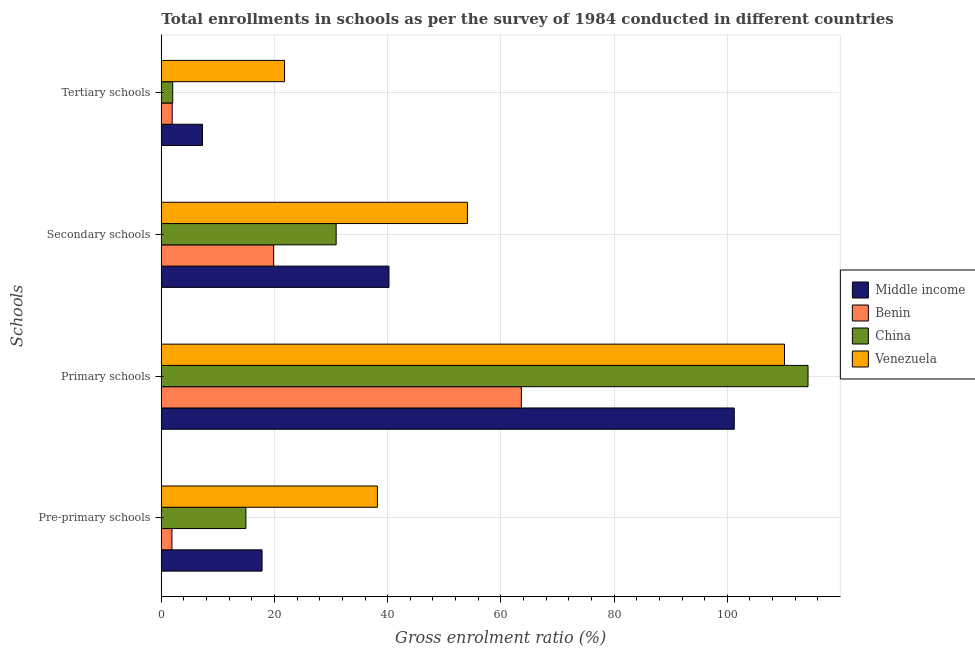How many different coloured bars are there?
Your answer should be very brief. 4. How many groups of bars are there?
Give a very brief answer. 4. Are the number of bars per tick equal to the number of legend labels?
Give a very brief answer. Yes. What is the label of the 1st group of bars from the top?
Your answer should be compact. Tertiary schools. What is the gross enrolment ratio in pre-primary schools in Middle income?
Offer a very short reply. 17.8. Across all countries, what is the maximum gross enrolment ratio in tertiary schools?
Your answer should be very brief. 21.77. Across all countries, what is the minimum gross enrolment ratio in secondary schools?
Provide a succinct answer. 19.84. In which country was the gross enrolment ratio in primary schools maximum?
Make the answer very short. China. In which country was the gross enrolment ratio in secondary schools minimum?
Your answer should be very brief. Benin. What is the total gross enrolment ratio in primary schools in the graph?
Your answer should be very brief. 389.23. What is the difference between the gross enrolment ratio in tertiary schools in Venezuela and that in Benin?
Offer a terse response. 19.86. What is the difference between the gross enrolment ratio in tertiary schools in Venezuela and the gross enrolment ratio in primary schools in China?
Offer a terse response. -92.49. What is the average gross enrolment ratio in secondary schools per country?
Ensure brevity in your answer.  36.26. What is the difference between the gross enrolment ratio in secondary schools and gross enrolment ratio in tertiary schools in Venezuela?
Ensure brevity in your answer.  32.31. In how many countries, is the gross enrolment ratio in pre-primary schools greater than 48 %?
Your answer should be compact. 0. What is the ratio of the gross enrolment ratio in tertiary schools in Middle income to that in Venezuela?
Keep it short and to the point. 0.33. What is the difference between the highest and the second highest gross enrolment ratio in tertiary schools?
Provide a short and direct response. 14.5. What is the difference between the highest and the lowest gross enrolment ratio in primary schools?
Ensure brevity in your answer.  50.65. In how many countries, is the gross enrolment ratio in secondary schools greater than the average gross enrolment ratio in secondary schools taken over all countries?
Your answer should be very brief. 2. Is it the case that in every country, the sum of the gross enrolment ratio in primary schools and gross enrolment ratio in tertiary schools is greater than the sum of gross enrolment ratio in pre-primary schools and gross enrolment ratio in secondary schools?
Provide a succinct answer. No. What does the 3rd bar from the top in Pre-primary schools represents?
Give a very brief answer. Benin. What does the 2nd bar from the bottom in Secondary schools represents?
Your answer should be very brief. Benin. Is it the case that in every country, the sum of the gross enrolment ratio in pre-primary schools and gross enrolment ratio in primary schools is greater than the gross enrolment ratio in secondary schools?
Give a very brief answer. Yes. Are all the bars in the graph horizontal?
Ensure brevity in your answer.  Yes. How many countries are there in the graph?
Ensure brevity in your answer.  4. Are the values on the major ticks of X-axis written in scientific E-notation?
Make the answer very short. No. Does the graph contain any zero values?
Your answer should be compact. No. Does the graph contain grids?
Ensure brevity in your answer.  Yes. How many legend labels are there?
Your answer should be compact. 4. What is the title of the graph?
Your response must be concise. Total enrollments in schools as per the survey of 1984 conducted in different countries. Does "Guinea" appear as one of the legend labels in the graph?
Your answer should be compact. No. What is the label or title of the Y-axis?
Make the answer very short. Schools. What is the Gross enrolment ratio (%) of Middle income in Pre-primary schools?
Provide a short and direct response. 17.8. What is the Gross enrolment ratio (%) of Benin in Pre-primary schools?
Offer a terse response. 1.88. What is the Gross enrolment ratio (%) of China in Pre-primary schools?
Your response must be concise. 14.94. What is the Gross enrolment ratio (%) of Venezuela in Pre-primary schools?
Your response must be concise. 38.18. What is the Gross enrolment ratio (%) of Middle income in Primary schools?
Provide a succinct answer. 101.23. What is the Gross enrolment ratio (%) of Benin in Primary schools?
Your answer should be very brief. 63.62. What is the Gross enrolment ratio (%) of China in Primary schools?
Your response must be concise. 114.26. What is the Gross enrolment ratio (%) in Venezuela in Primary schools?
Give a very brief answer. 110.11. What is the Gross enrolment ratio (%) of Middle income in Secondary schools?
Provide a short and direct response. 40.22. What is the Gross enrolment ratio (%) in Benin in Secondary schools?
Your response must be concise. 19.84. What is the Gross enrolment ratio (%) of China in Secondary schools?
Make the answer very short. 30.89. What is the Gross enrolment ratio (%) in Venezuela in Secondary schools?
Ensure brevity in your answer.  54.09. What is the Gross enrolment ratio (%) of Middle income in Tertiary schools?
Ensure brevity in your answer.  7.28. What is the Gross enrolment ratio (%) of Benin in Tertiary schools?
Make the answer very short. 1.92. What is the Gross enrolment ratio (%) in China in Tertiary schools?
Provide a succinct answer. 2.02. What is the Gross enrolment ratio (%) in Venezuela in Tertiary schools?
Provide a succinct answer. 21.77. Across all Schools, what is the maximum Gross enrolment ratio (%) of Middle income?
Your answer should be compact. 101.23. Across all Schools, what is the maximum Gross enrolment ratio (%) of Benin?
Provide a short and direct response. 63.62. Across all Schools, what is the maximum Gross enrolment ratio (%) in China?
Give a very brief answer. 114.26. Across all Schools, what is the maximum Gross enrolment ratio (%) in Venezuela?
Provide a short and direct response. 110.11. Across all Schools, what is the minimum Gross enrolment ratio (%) in Middle income?
Provide a short and direct response. 7.28. Across all Schools, what is the minimum Gross enrolment ratio (%) in Benin?
Provide a succinct answer. 1.88. Across all Schools, what is the minimum Gross enrolment ratio (%) in China?
Provide a short and direct response. 2.02. Across all Schools, what is the minimum Gross enrolment ratio (%) in Venezuela?
Ensure brevity in your answer.  21.77. What is the total Gross enrolment ratio (%) in Middle income in the graph?
Provide a short and direct response. 166.53. What is the total Gross enrolment ratio (%) in Benin in the graph?
Offer a very short reply. 87.25. What is the total Gross enrolment ratio (%) in China in the graph?
Make the answer very short. 162.12. What is the total Gross enrolment ratio (%) in Venezuela in the graph?
Ensure brevity in your answer.  224.15. What is the difference between the Gross enrolment ratio (%) of Middle income in Pre-primary schools and that in Primary schools?
Ensure brevity in your answer.  -83.43. What is the difference between the Gross enrolment ratio (%) in Benin in Pre-primary schools and that in Primary schools?
Provide a short and direct response. -61.74. What is the difference between the Gross enrolment ratio (%) in China in Pre-primary schools and that in Primary schools?
Provide a short and direct response. -99.32. What is the difference between the Gross enrolment ratio (%) in Venezuela in Pre-primary schools and that in Primary schools?
Provide a short and direct response. -71.93. What is the difference between the Gross enrolment ratio (%) of Middle income in Pre-primary schools and that in Secondary schools?
Offer a terse response. -22.42. What is the difference between the Gross enrolment ratio (%) of Benin in Pre-primary schools and that in Secondary schools?
Your answer should be very brief. -17.97. What is the difference between the Gross enrolment ratio (%) of China in Pre-primary schools and that in Secondary schools?
Provide a succinct answer. -15.95. What is the difference between the Gross enrolment ratio (%) of Venezuela in Pre-primary schools and that in Secondary schools?
Keep it short and to the point. -15.9. What is the difference between the Gross enrolment ratio (%) of Middle income in Pre-primary schools and that in Tertiary schools?
Give a very brief answer. 10.52. What is the difference between the Gross enrolment ratio (%) in Benin in Pre-primary schools and that in Tertiary schools?
Offer a very short reply. -0.04. What is the difference between the Gross enrolment ratio (%) of China in Pre-primary schools and that in Tertiary schools?
Give a very brief answer. 12.93. What is the difference between the Gross enrolment ratio (%) in Venezuela in Pre-primary schools and that in Tertiary schools?
Provide a short and direct response. 16.41. What is the difference between the Gross enrolment ratio (%) in Middle income in Primary schools and that in Secondary schools?
Provide a short and direct response. 61.01. What is the difference between the Gross enrolment ratio (%) in Benin in Primary schools and that in Secondary schools?
Your answer should be very brief. 43.78. What is the difference between the Gross enrolment ratio (%) in China in Primary schools and that in Secondary schools?
Your answer should be very brief. 83.37. What is the difference between the Gross enrolment ratio (%) of Venezuela in Primary schools and that in Secondary schools?
Your response must be concise. 56.02. What is the difference between the Gross enrolment ratio (%) of Middle income in Primary schools and that in Tertiary schools?
Provide a succinct answer. 93.96. What is the difference between the Gross enrolment ratio (%) of Benin in Primary schools and that in Tertiary schools?
Offer a very short reply. 61.7. What is the difference between the Gross enrolment ratio (%) of China in Primary schools and that in Tertiary schools?
Your answer should be very brief. 112.25. What is the difference between the Gross enrolment ratio (%) of Venezuela in Primary schools and that in Tertiary schools?
Ensure brevity in your answer.  88.34. What is the difference between the Gross enrolment ratio (%) of Middle income in Secondary schools and that in Tertiary schools?
Offer a terse response. 32.95. What is the difference between the Gross enrolment ratio (%) in Benin in Secondary schools and that in Tertiary schools?
Your answer should be very brief. 17.92. What is the difference between the Gross enrolment ratio (%) of China in Secondary schools and that in Tertiary schools?
Provide a short and direct response. 28.87. What is the difference between the Gross enrolment ratio (%) in Venezuela in Secondary schools and that in Tertiary schools?
Your answer should be compact. 32.31. What is the difference between the Gross enrolment ratio (%) in Middle income in Pre-primary schools and the Gross enrolment ratio (%) in Benin in Primary schools?
Make the answer very short. -45.82. What is the difference between the Gross enrolment ratio (%) in Middle income in Pre-primary schools and the Gross enrolment ratio (%) in China in Primary schools?
Your response must be concise. -96.46. What is the difference between the Gross enrolment ratio (%) of Middle income in Pre-primary schools and the Gross enrolment ratio (%) of Venezuela in Primary schools?
Your answer should be compact. -92.31. What is the difference between the Gross enrolment ratio (%) in Benin in Pre-primary schools and the Gross enrolment ratio (%) in China in Primary schools?
Your answer should be compact. -112.39. What is the difference between the Gross enrolment ratio (%) in Benin in Pre-primary schools and the Gross enrolment ratio (%) in Venezuela in Primary schools?
Make the answer very short. -108.23. What is the difference between the Gross enrolment ratio (%) of China in Pre-primary schools and the Gross enrolment ratio (%) of Venezuela in Primary schools?
Keep it short and to the point. -95.17. What is the difference between the Gross enrolment ratio (%) in Middle income in Pre-primary schools and the Gross enrolment ratio (%) in Benin in Secondary schools?
Provide a succinct answer. -2.04. What is the difference between the Gross enrolment ratio (%) in Middle income in Pre-primary schools and the Gross enrolment ratio (%) in China in Secondary schools?
Give a very brief answer. -13.09. What is the difference between the Gross enrolment ratio (%) of Middle income in Pre-primary schools and the Gross enrolment ratio (%) of Venezuela in Secondary schools?
Provide a succinct answer. -36.29. What is the difference between the Gross enrolment ratio (%) of Benin in Pre-primary schools and the Gross enrolment ratio (%) of China in Secondary schools?
Make the answer very short. -29.02. What is the difference between the Gross enrolment ratio (%) in Benin in Pre-primary schools and the Gross enrolment ratio (%) in Venezuela in Secondary schools?
Give a very brief answer. -52.21. What is the difference between the Gross enrolment ratio (%) of China in Pre-primary schools and the Gross enrolment ratio (%) of Venezuela in Secondary schools?
Provide a short and direct response. -39.14. What is the difference between the Gross enrolment ratio (%) in Middle income in Pre-primary schools and the Gross enrolment ratio (%) in Benin in Tertiary schools?
Keep it short and to the point. 15.88. What is the difference between the Gross enrolment ratio (%) of Middle income in Pre-primary schools and the Gross enrolment ratio (%) of China in Tertiary schools?
Ensure brevity in your answer.  15.78. What is the difference between the Gross enrolment ratio (%) in Middle income in Pre-primary schools and the Gross enrolment ratio (%) in Venezuela in Tertiary schools?
Offer a terse response. -3.97. What is the difference between the Gross enrolment ratio (%) of Benin in Pre-primary schools and the Gross enrolment ratio (%) of China in Tertiary schools?
Your answer should be very brief. -0.14. What is the difference between the Gross enrolment ratio (%) of Benin in Pre-primary schools and the Gross enrolment ratio (%) of Venezuela in Tertiary schools?
Your answer should be compact. -19.9. What is the difference between the Gross enrolment ratio (%) of China in Pre-primary schools and the Gross enrolment ratio (%) of Venezuela in Tertiary schools?
Make the answer very short. -6.83. What is the difference between the Gross enrolment ratio (%) in Middle income in Primary schools and the Gross enrolment ratio (%) in Benin in Secondary schools?
Provide a short and direct response. 81.39. What is the difference between the Gross enrolment ratio (%) of Middle income in Primary schools and the Gross enrolment ratio (%) of China in Secondary schools?
Make the answer very short. 70.34. What is the difference between the Gross enrolment ratio (%) of Middle income in Primary schools and the Gross enrolment ratio (%) of Venezuela in Secondary schools?
Offer a terse response. 47.15. What is the difference between the Gross enrolment ratio (%) of Benin in Primary schools and the Gross enrolment ratio (%) of China in Secondary schools?
Make the answer very short. 32.73. What is the difference between the Gross enrolment ratio (%) of Benin in Primary schools and the Gross enrolment ratio (%) of Venezuela in Secondary schools?
Your response must be concise. 9.53. What is the difference between the Gross enrolment ratio (%) of China in Primary schools and the Gross enrolment ratio (%) of Venezuela in Secondary schools?
Give a very brief answer. 60.18. What is the difference between the Gross enrolment ratio (%) in Middle income in Primary schools and the Gross enrolment ratio (%) in Benin in Tertiary schools?
Offer a terse response. 99.32. What is the difference between the Gross enrolment ratio (%) of Middle income in Primary schools and the Gross enrolment ratio (%) of China in Tertiary schools?
Ensure brevity in your answer.  99.22. What is the difference between the Gross enrolment ratio (%) in Middle income in Primary schools and the Gross enrolment ratio (%) in Venezuela in Tertiary schools?
Provide a short and direct response. 79.46. What is the difference between the Gross enrolment ratio (%) in Benin in Primary schools and the Gross enrolment ratio (%) in China in Tertiary schools?
Your response must be concise. 61.6. What is the difference between the Gross enrolment ratio (%) in Benin in Primary schools and the Gross enrolment ratio (%) in Venezuela in Tertiary schools?
Ensure brevity in your answer.  41.84. What is the difference between the Gross enrolment ratio (%) of China in Primary schools and the Gross enrolment ratio (%) of Venezuela in Tertiary schools?
Provide a short and direct response. 92.49. What is the difference between the Gross enrolment ratio (%) in Middle income in Secondary schools and the Gross enrolment ratio (%) in Benin in Tertiary schools?
Your answer should be compact. 38.31. What is the difference between the Gross enrolment ratio (%) of Middle income in Secondary schools and the Gross enrolment ratio (%) of China in Tertiary schools?
Give a very brief answer. 38.21. What is the difference between the Gross enrolment ratio (%) of Middle income in Secondary schools and the Gross enrolment ratio (%) of Venezuela in Tertiary schools?
Your answer should be very brief. 18.45. What is the difference between the Gross enrolment ratio (%) in Benin in Secondary schools and the Gross enrolment ratio (%) in China in Tertiary schools?
Provide a succinct answer. 17.82. What is the difference between the Gross enrolment ratio (%) in Benin in Secondary schools and the Gross enrolment ratio (%) in Venezuela in Tertiary schools?
Offer a terse response. -1.93. What is the difference between the Gross enrolment ratio (%) in China in Secondary schools and the Gross enrolment ratio (%) in Venezuela in Tertiary schools?
Make the answer very short. 9.12. What is the average Gross enrolment ratio (%) in Middle income per Schools?
Your answer should be compact. 41.63. What is the average Gross enrolment ratio (%) in Benin per Schools?
Make the answer very short. 21.81. What is the average Gross enrolment ratio (%) of China per Schools?
Provide a short and direct response. 40.53. What is the average Gross enrolment ratio (%) of Venezuela per Schools?
Your answer should be compact. 56.04. What is the difference between the Gross enrolment ratio (%) in Middle income and Gross enrolment ratio (%) in Benin in Pre-primary schools?
Offer a very short reply. 15.92. What is the difference between the Gross enrolment ratio (%) in Middle income and Gross enrolment ratio (%) in China in Pre-primary schools?
Provide a short and direct response. 2.86. What is the difference between the Gross enrolment ratio (%) in Middle income and Gross enrolment ratio (%) in Venezuela in Pre-primary schools?
Ensure brevity in your answer.  -20.38. What is the difference between the Gross enrolment ratio (%) in Benin and Gross enrolment ratio (%) in China in Pre-primary schools?
Your answer should be very brief. -13.07. What is the difference between the Gross enrolment ratio (%) of Benin and Gross enrolment ratio (%) of Venezuela in Pre-primary schools?
Offer a terse response. -36.3. What is the difference between the Gross enrolment ratio (%) of China and Gross enrolment ratio (%) of Venezuela in Pre-primary schools?
Your response must be concise. -23.24. What is the difference between the Gross enrolment ratio (%) in Middle income and Gross enrolment ratio (%) in Benin in Primary schools?
Give a very brief answer. 37.62. What is the difference between the Gross enrolment ratio (%) of Middle income and Gross enrolment ratio (%) of China in Primary schools?
Provide a short and direct response. -13.03. What is the difference between the Gross enrolment ratio (%) of Middle income and Gross enrolment ratio (%) of Venezuela in Primary schools?
Give a very brief answer. -8.88. What is the difference between the Gross enrolment ratio (%) of Benin and Gross enrolment ratio (%) of China in Primary schools?
Give a very brief answer. -50.65. What is the difference between the Gross enrolment ratio (%) in Benin and Gross enrolment ratio (%) in Venezuela in Primary schools?
Keep it short and to the point. -46.49. What is the difference between the Gross enrolment ratio (%) of China and Gross enrolment ratio (%) of Venezuela in Primary schools?
Offer a very short reply. 4.15. What is the difference between the Gross enrolment ratio (%) of Middle income and Gross enrolment ratio (%) of Benin in Secondary schools?
Your response must be concise. 20.38. What is the difference between the Gross enrolment ratio (%) of Middle income and Gross enrolment ratio (%) of China in Secondary schools?
Your answer should be compact. 9.33. What is the difference between the Gross enrolment ratio (%) in Middle income and Gross enrolment ratio (%) in Venezuela in Secondary schools?
Offer a terse response. -13.86. What is the difference between the Gross enrolment ratio (%) of Benin and Gross enrolment ratio (%) of China in Secondary schools?
Provide a succinct answer. -11.05. What is the difference between the Gross enrolment ratio (%) in Benin and Gross enrolment ratio (%) in Venezuela in Secondary schools?
Keep it short and to the point. -34.24. What is the difference between the Gross enrolment ratio (%) of China and Gross enrolment ratio (%) of Venezuela in Secondary schools?
Keep it short and to the point. -23.19. What is the difference between the Gross enrolment ratio (%) of Middle income and Gross enrolment ratio (%) of Benin in Tertiary schools?
Provide a short and direct response. 5.36. What is the difference between the Gross enrolment ratio (%) of Middle income and Gross enrolment ratio (%) of China in Tertiary schools?
Ensure brevity in your answer.  5.26. What is the difference between the Gross enrolment ratio (%) in Middle income and Gross enrolment ratio (%) in Venezuela in Tertiary schools?
Ensure brevity in your answer.  -14.5. What is the difference between the Gross enrolment ratio (%) of Benin and Gross enrolment ratio (%) of China in Tertiary schools?
Your response must be concise. -0.1. What is the difference between the Gross enrolment ratio (%) in Benin and Gross enrolment ratio (%) in Venezuela in Tertiary schools?
Your answer should be very brief. -19.86. What is the difference between the Gross enrolment ratio (%) of China and Gross enrolment ratio (%) of Venezuela in Tertiary schools?
Ensure brevity in your answer.  -19.76. What is the ratio of the Gross enrolment ratio (%) of Middle income in Pre-primary schools to that in Primary schools?
Your answer should be very brief. 0.18. What is the ratio of the Gross enrolment ratio (%) in Benin in Pre-primary schools to that in Primary schools?
Ensure brevity in your answer.  0.03. What is the ratio of the Gross enrolment ratio (%) of China in Pre-primary schools to that in Primary schools?
Your answer should be compact. 0.13. What is the ratio of the Gross enrolment ratio (%) of Venezuela in Pre-primary schools to that in Primary schools?
Keep it short and to the point. 0.35. What is the ratio of the Gross enrolment ratio (%) of Middle income in Pre-primary schools to that in Secondary schools?
Give a very brief answer. 0.44. What is the ratio of the Gross enrolment ratio (%) of Benin in Pre-primary schools to that in Secondary schools?
Ensure brevity in your answer.  0.09. What is the ratio of the Gross enrolment ratio (%) in China in Pre-primary schools to that in Secondary schools?
Ensure brevity in your answer.  0.48. What is the ratio of the Gross enrolment ratio (%) of Venezuela in Pre-primary schools to that in Secondary schools?
Ensure brevity in your answer.  0.71. What is the ratio of the Gross enrolment ratio (%) in Middle income in Pre-primary schools to that in Tertiary schools?
Offer a terse response. 2.45. What is the ratio of the Gross enrolment ratio (%) in Benin in Pre-primary schools to that in Tertiary schools?
Your response must be concise. 0.98. What is the ratio of the Gross enrolment ratio (%) of China in Pre-primary schools to that in Tertiary schools?
Your answer should be compact. 7.41. What is the ratio of the Gross enrolment ratio (%) of Venezuela in Pre-primary schools to that in Tertiary schools?
Offer a terse response. 1.75. What is the ratio of the Gross enrolment ratio (%) of Middle income in Primary schools to that in Secondary schools?
Provide a succinct answer. 2.52. What is the ratio of the Gross enrolment ratio (%) in Benin in Primary schools to that in Secondary schools?
Provide a short and direct response. 3.21. What is the ratio of the Gross enrolment ratio (%) in China in Primary schools to that in Secondary schools?
Keep it short and to the point. 3.7. What is the ratio of the Gross enrolment ratio (%) in Venezuela in Primary schools to that in Secondary schools?
Ensure brevity in your answer.  2.04. What is the ratio of the Gross enrolment ratio (%) in Middle income in Primary schools to that in Tertiary schools?
Your response must be concise. 13.91. What is the ratio of the Gross enrolment ratio (%) in Benin in Primary schools to that in Tertiary schools?
Give a very brief answer. 33.18. What is the ratio of the Gross enrolment ratio (%) of China in Primary schools to that in Tertiary schools?
Your answer should be compact. 56.64. What is the ratio of the Gross enrolment ratio (%) in Venezuela in Primary schools to that in Tertiary schools?
Ensure brevity in your answer.  5.06. What is the ratio of the Gross enrolment ratio (%) of Middle income in Secondary schools to that in Tertiary schools?
Your answer should be very brief. 5.53. What is the ratio of the Gross enrolment ratio (%) of Benin in Secondary schools to that in Tertiary schools?
Offer a very short reply. 10.35. What is the ratio of the Gross enrolment ratio (%) of China in Secondary schools to that in Tertiary schools?
Keep it short and to the point. 15.31. What is the ratio of the Gross enrolment ratio (%) of Venezuela in Secondary schools to that in Tertiary schools?
Your response must be concise. 2.48. What is the difference between the highest and the second highest Gross enrolment ratio (%) in Middle income?
Provide a short and direct response. 61.01. What is the difference between the highest and the second highest Gross enrolment ratio (%) in Benin?
Keep it short and to the point. 43.78. What is the difference between the highest and the second highest Gross enrolment ratio (%) in China?
Ensure brevity in your answer.  83.37. What is the difference between the highest and the second highest Gross enrolment ratio (%) of Venezuela?
Ensure brevity in your answer.  56.02. What is the difference between the highest and the lowest Gross enrolment ratio (%) in Middle income?
Provide a short and direct response. 93.96. What is the difference between the highest and the lowest Gross enrolment ratio (%) of Benin?
Provide a succinct answer. 61.74. What is the difference between the highest and the lowest Gross enrolment ratio (%) of China?
Your answer should be compact. 112.25. What is the difference between the highest and the lowest Gross enrolment ratio (%) of Venezuela?
Your answer should be very brief. 88.34. 